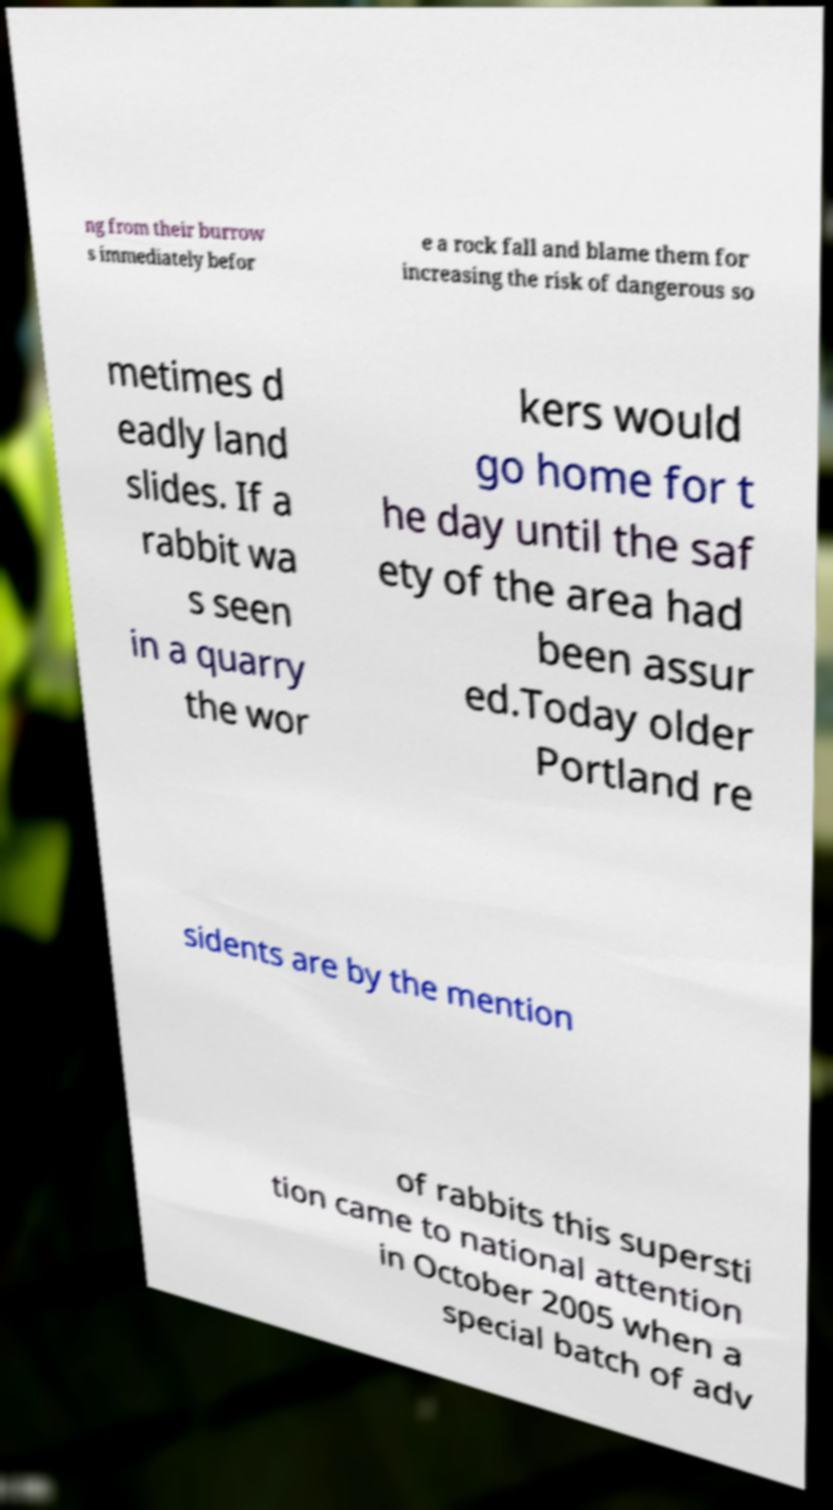I need the written content from this picture converted into text. Can you do that? ng from their burrow s immediately befor e a rock fall and blame them for increasing the risk of dangerous so metimes d eadly land slides. If a rabbit wa s seen in a quarry the wor kers would go home for t he day until the saf ety of the area had been assur ed.Today older Portland re sidents are by the mention of rabbits this supersti tion came to national attention in October 2005 when a special batch of adv 